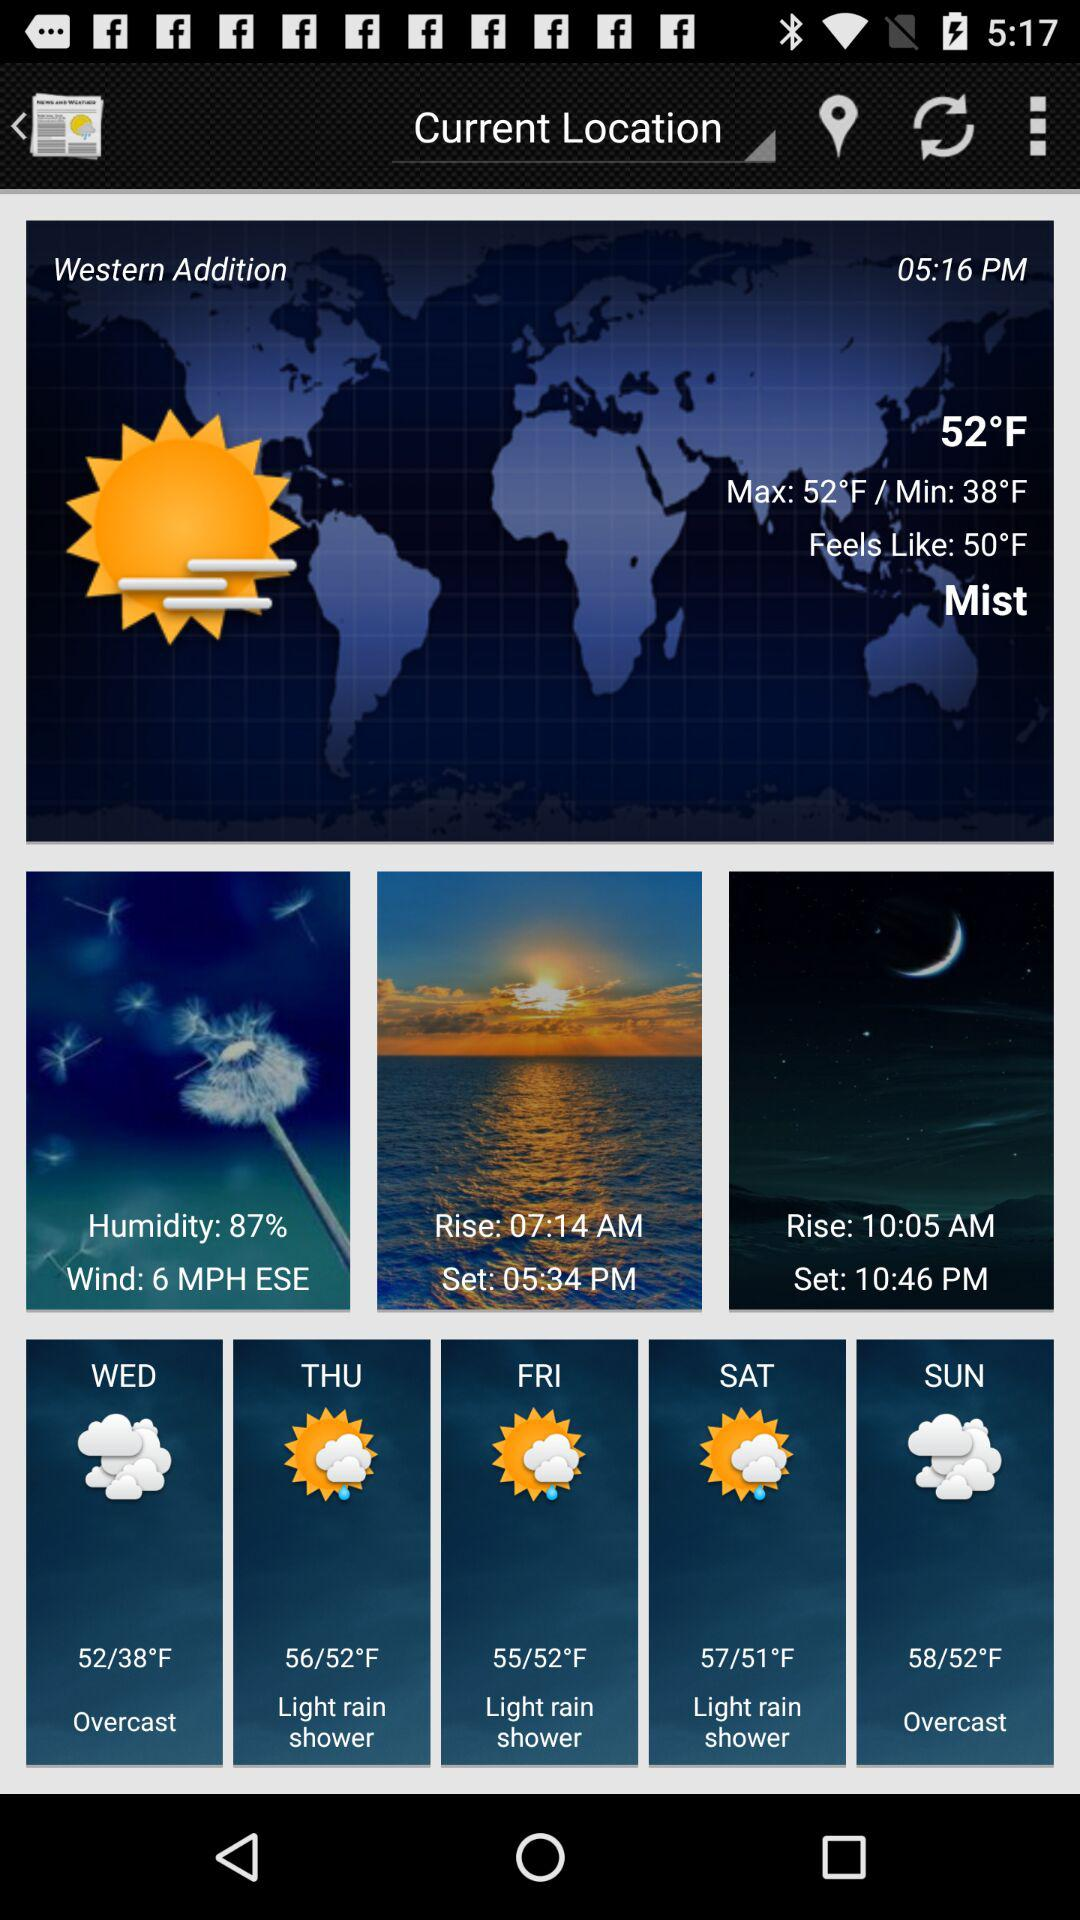What is the humidity percentage? The humidity percentage is 87. 